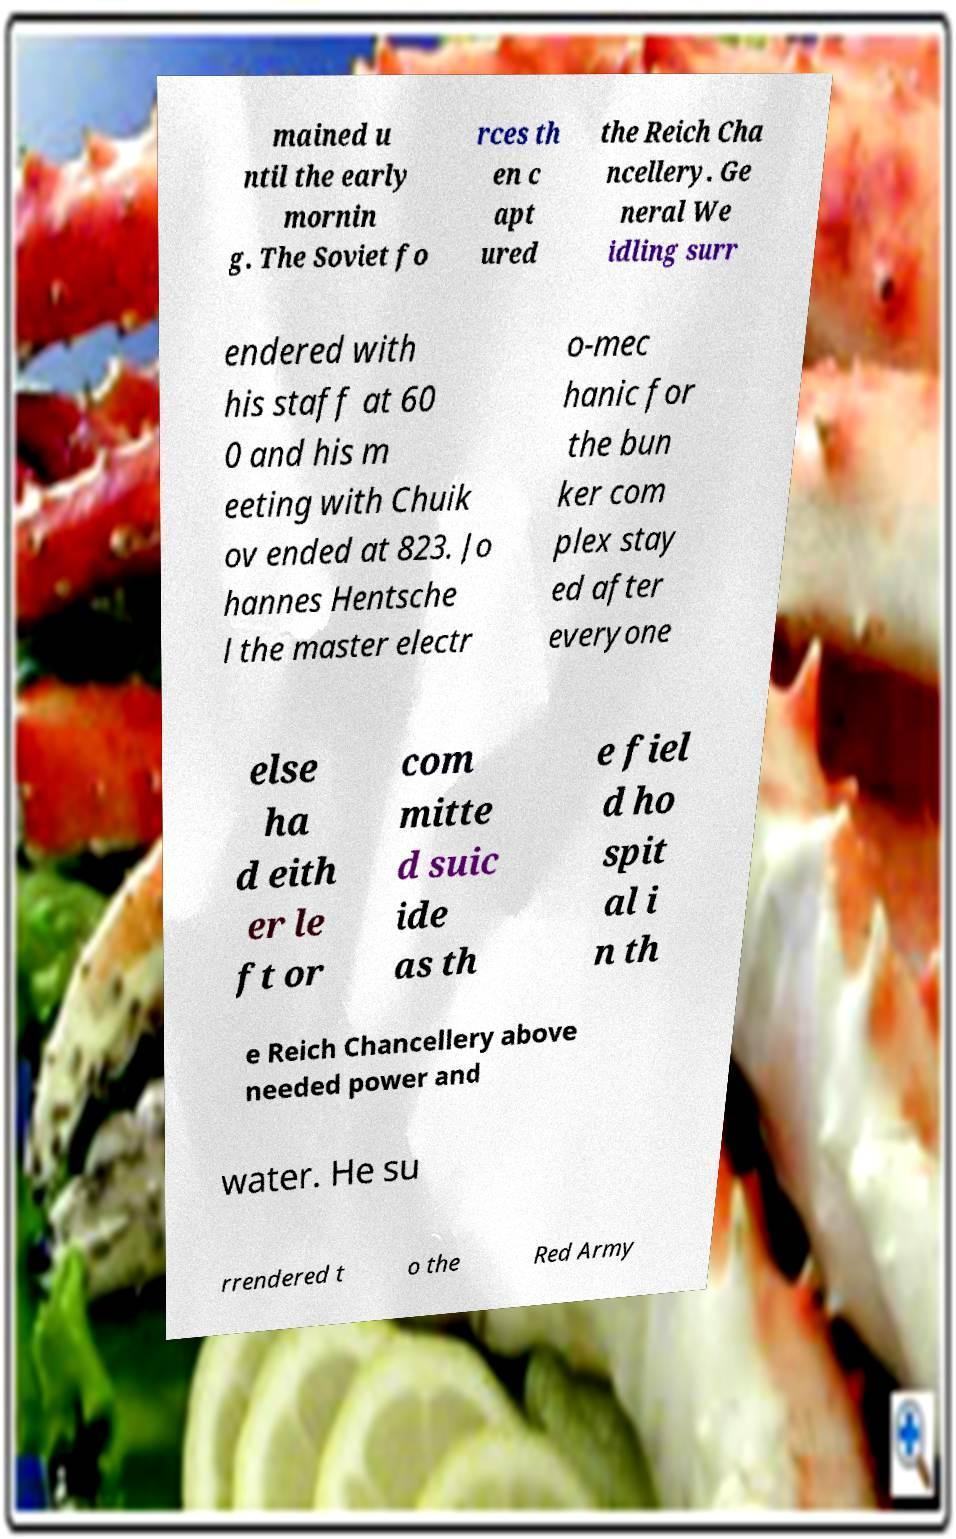What messages or text are displayed in this image? I need them in a readable, typed format. mained u ntil the early mornin g. The Soviet fo rces th en c apt ured the Reich Cha ncellery. Ge neral We idling surr endered with his staff at 60 0 and his m eeting with Chuik ov ended at 823. Jo hannes Hentsche l the master electr o-mec hanic for the bun ker com plex stay ed after everyone else ha d eith er le ft or com mitte d suic ide as th e fiel d ho spit al i n th e Reich Chancellery above needed power and water. He su rrendered t o the Red Army 